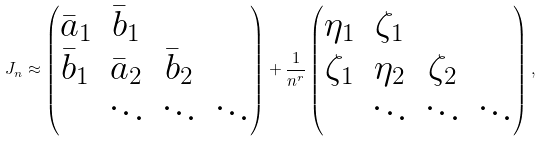Convert formula to latex. <formula><loc_0><loc_0><loc_500><loc_500>J _ { n } \approx \begin{pmatrix} \bar { a } _ { 1 } & \bar { b } _ { 1 } \\ \bar { b } _ { 1 } & \bar { a } _ { 2 } & \bar { b } _ { 2 } \\ & \ddots & \ddots & \ddots \end{pmatrix} + \frac { 1 } { n ^ { r } } \begin{pmatrix} \eta _ { 1 } & \zeta _ { 1 } \\ \zeta _ { 1 } & \eta _ { 2 } & \zeta _ { 2 } \\ & \ddots & \ddots & \ddots \end{pmatrix} ,</formula> 